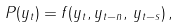Convert formula to latex. <formula><loc_0><loc_0><loc_500><loc_500>P ( y _ { t } ) = f ( y _ { t } , y _ { t - n } , \, y _ { t - s } ) \, ,</formula> 